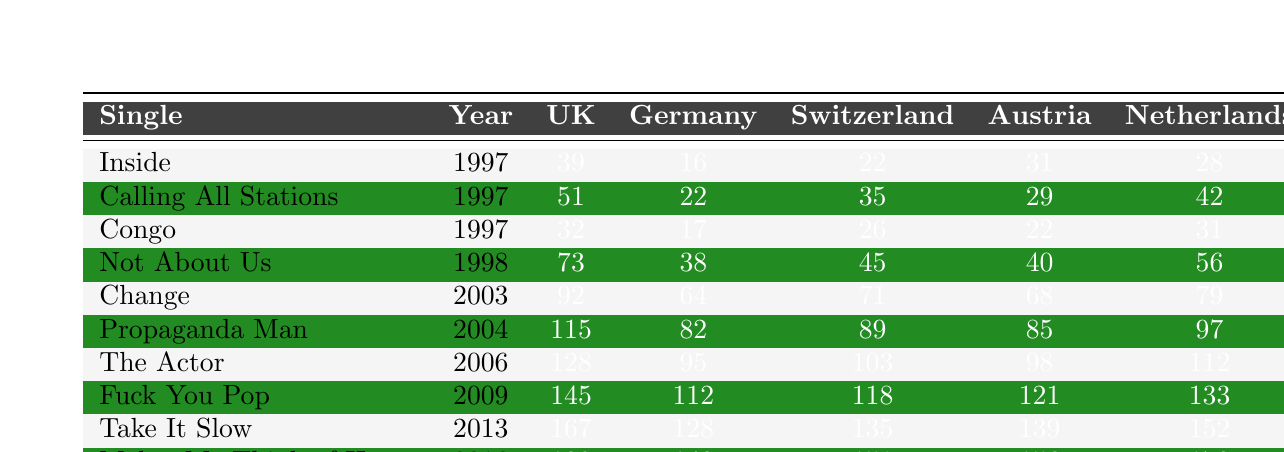What was the highest chart position for "Inside"? The table shows that "Inside" reached position 39 in the UK in 1997, which is the song's highest chart position listed.
Answer: 39 Which single achieved the best performance in Germany? Upon reviewing the table, "Congo" reached position 17 in Germany, which is the best performance compared to other singles listed.
Answer: 17 What is the average chart position of "Not About Us" across all countries? The positions for "Not About Us" are 73 (UK), 38 (Germany), 45 (Switzerland), 40 (Austria), and 56 (Netherlands). The average is calculated by summing these values (73 + 38 + 45 + 40 + 56) = 252, then dividing by 5 to get 252/5 = 50.4
Answer: 50.4 Did "Makes Me Think of Home" perform better in Switzerland or Austria? "Makes Me Think of Home" reached position 151 in Switzerland and 156 in Austria. Since 151 is lower than 156, it performed better in Switzerland.
Answer: Yes What is the difference in chart position for "Congo" between the UK and Germany? In the UK, "Congo" reached position 32, while in Germany, it reached position 17. The difference is 32 - 17 = 15.
Answer: 15 Which single has the highest chart position in the Netherlands? By examining the chart positions for each single in the Netherlands, "Makes Me Think of Home" has the highest position at 170.
Answer: 170 How many singles reached a higher position in Germany than in the UK? Look through the table, and the singles "Inside," "Congo," and "Not About Us" reached higher positions in Germany than the UK. This gives a total of 3 singles.
Answer: 3 Was there any single that peaked in the top 20 in Germany? The data shows that "Inside" peaked at 16 in Germany, which is within the top 20.
Answer: Yes Which single took the longest to enter the charts, based on the years listed? Reviewing the years, "Makes Me Think of Home" released in 2016 is the latest single listed, thus taking the longest to enter the charts.
Answer: Makes Me Think of Home Calculate the total sum of chart positions for "Change" across all countries? The chart positions for "Change" are 92 (UK), 64 (Germany), 71 (Switzerland), 68 (Austria), and 79 (Netherlands). The total is calculated as 92 + 64 + 71 + 68 + 79 = 374.
Answer: 374 